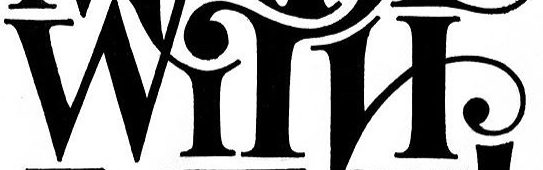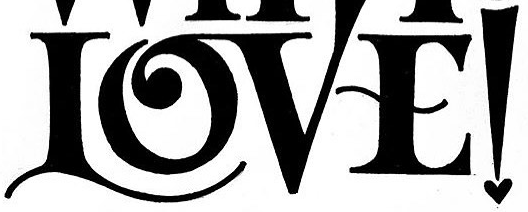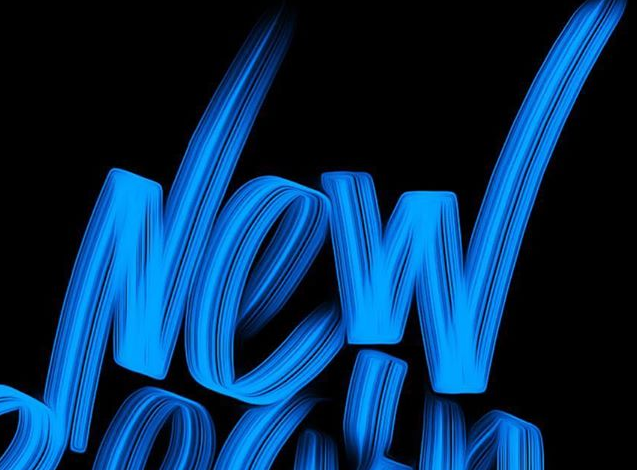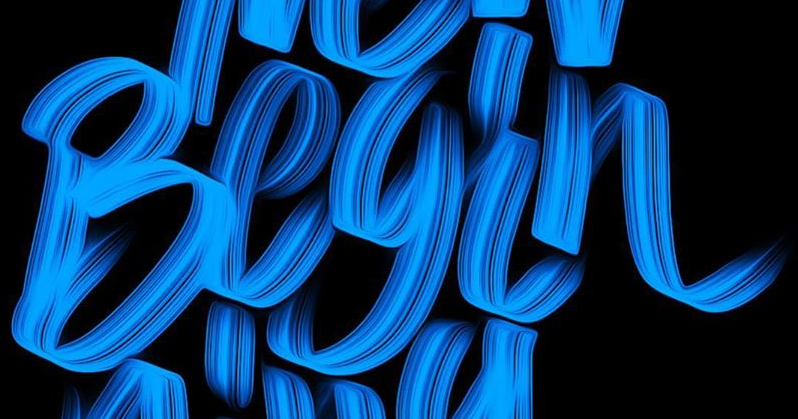Read the text content from these images in order, separated by a semicolon. WITH; LOVE!; New; Begin 